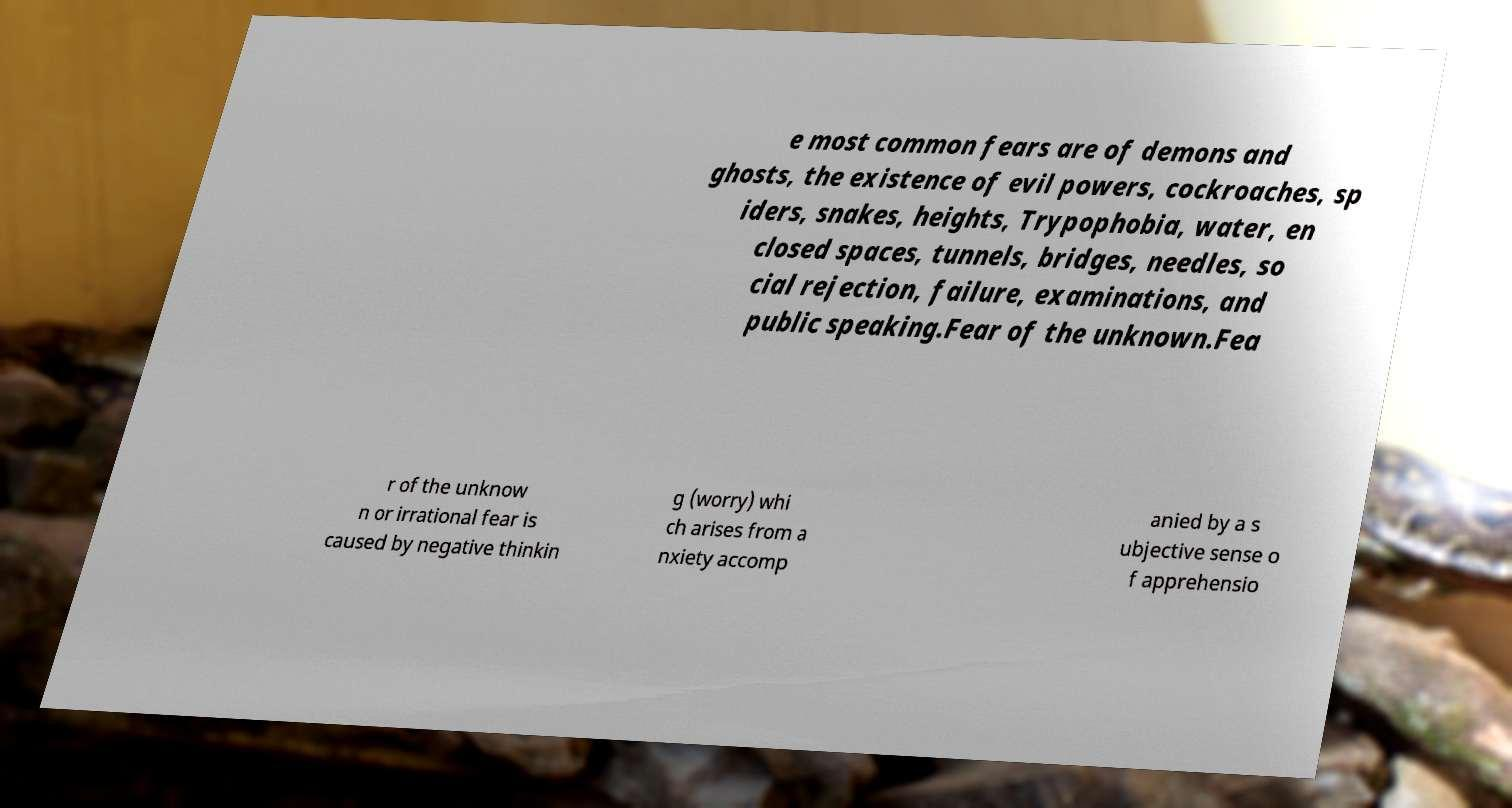Could you extract and type out the text from this image? e most common fears are of demons and ghosts, the existence of evil powers, cockroaches, sp iders, snakes, heights, Trypophobia, water, en closed spaces, tunnels, bridges, needles, so cial rejection, failure, examinations, and public speaking.Fear of the unknown.Fea r of the unknow n or irrational fear is caused by negative thinkin g (worry) whi ch arises from a nxiety accomp anied by a s ubjective sense o f apprehensio 